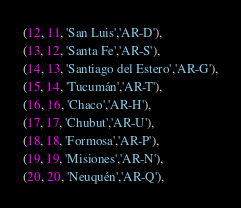<code> <loc_0><loc_0><loc_500><loc_500><_SQL_>(12, 11, 'San Luis','AR-D'),
(13, 12, 'Santa Fe','AR-S'),
(14, 13, 'Santiago del Estero','AR-G'),
(15, 14, 'Tucumán','AR-T'),
(16, 16, 'Chaco','AR-H'),
(17, 17, 'Chubut','AR-U'),
(18, 18, 'Formosa','AR-P'),
(19, 19, 'Misiones','AR-N'),
(20, 20, 'Neuquén','AR-Q'),</code> 